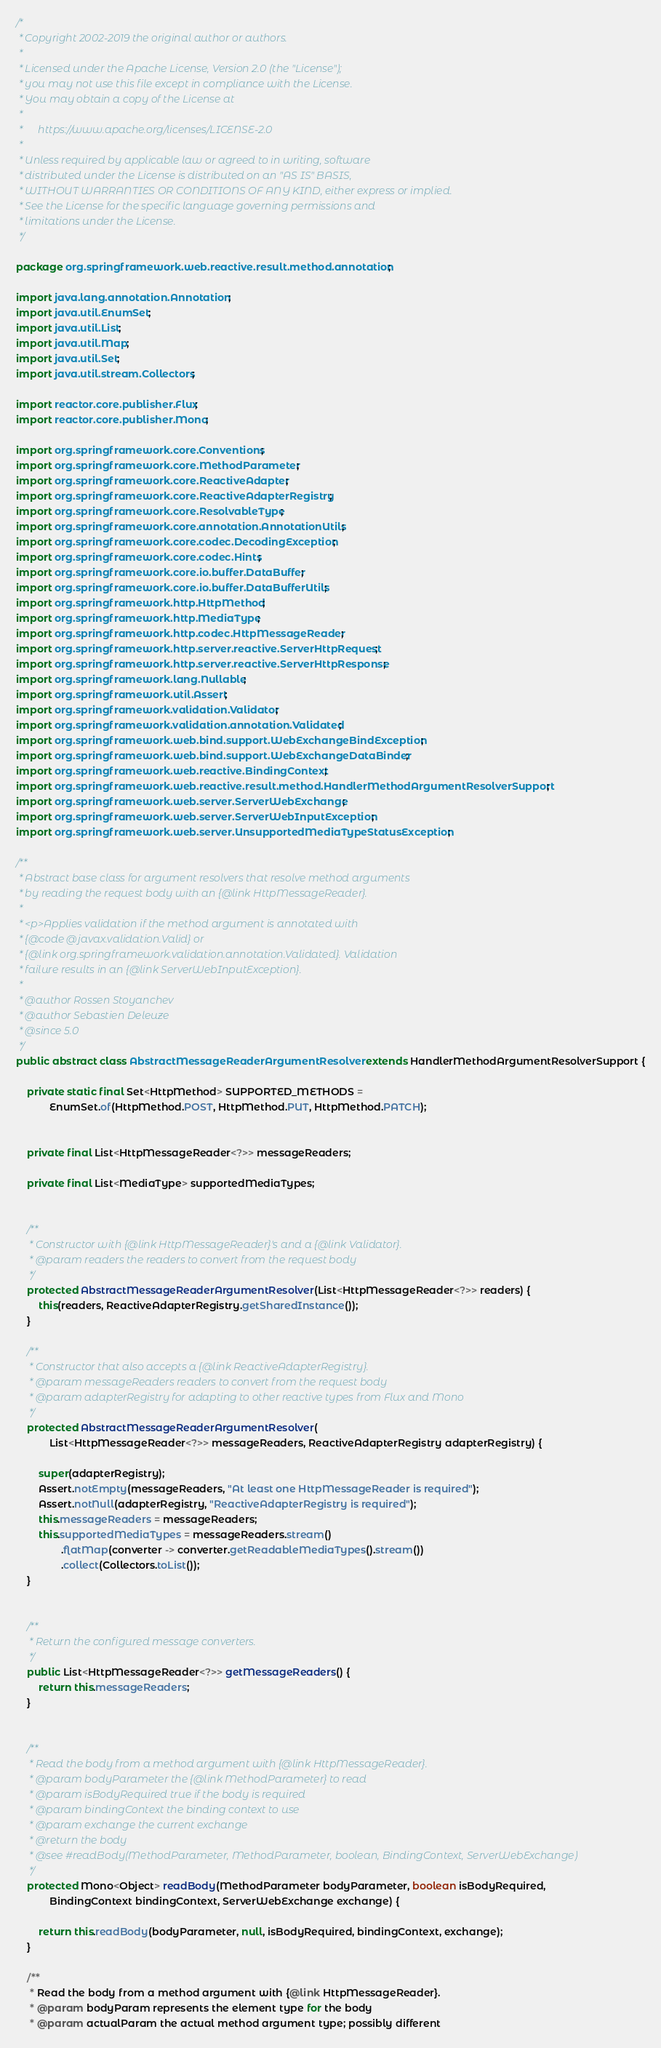<code> <loc_0><loc_0><loc_500><loc_500><_Java_>/*
 * Copyright 2002-2019 the original author or authors.
 *
 * Licensed under the Apache License, Version 2.0 (the "License");
 * you may not use this file except in compliance with the License.
 * You may obtain a copy of the License at
 *
 *      https://www.apache.org/licenses/LICENSE-2.0
 *
 * Unless required by applicable law or agreed to in writing, software
 * distributed under the License is distributed on an "AS IS" BASIS,
 * WITHOUT WARRANTIES OR CONDITIONS OF ANY KIND, either express or implied.
 * See the License for the specific language governing permissions and
 * limitations under the License.
 */

package org.springframework.web.reactive.result.method.annotation;

import java.lang.annotation.Annotation;
import java.util.EnumSet;
import java.util.List;
import java.util.Map;
import java.util.Set;
import java.util.stream.Collectors;

import reactor.core.publisher.Flux;
import reactor.core.publisher.Mono;

import org.springframework.core.Conventions;
import org.springframework.core.MethodParameter;
import org.springframework.core.ReactiveAdapter;
import org.springframework.core.ReactiveAdapterRegistry;
import org.springframework.core.ResolvableType;
import org.springframework.core.annotation.AnnotationUtils;
import org.springframework.core.codec.DecodingException;
import org.springframework.core.codec.Hints;
import org.springframework.core.io.buffer.DataBuffer;
import org.springframework.core.io.buffer.DataBufferUtils;
import org.springframework.http.HttpMethod;
import org.springframework.http.MediaType;
import org.springframework.http.codec.HttpMessageReader;
import org.springframework.http.server.reactive.ServerHttpRequest;
import org.springframework.http.server.reactive.ServerHttpResponse;
import org.springframework.lang.Nullable;
import org.springframework.util.Assert;
import org.springframework.validation.Validator;
import org.springframework.validation.annotation.Validated;
import org.springframework.web.bind.support.WebExchangeBindException;
import org.springframework.web.bind.support.WebExchangeDataBinder;
import org.springframework.web.reactive.BindingContext;
import org.springframework.web.reactive.result.method.HandlerMethodArgumentResolverSupport;
import org.springframework.web.server.ServerWebExchange;
import org.springframework.web.server.ServerWebInputException;
import org.springframework.web.server.UnsupportedMediaTypeStatusException;

/**
 * Abstract base class for argument resolvers that resolve method arguments
 * by reading the request body with an {@link HttpMessageReader}.
 *
 * <p>Applies validation if the method argument is annotated with
 * {@code @javax.validation.Valid} or
 * {@link org.springframework.validation.annotation.Validated}. Validation
 * failure results in an {@link ServerWebInputException}.
 *
 * @author Rossen Stoyanchev
 * @author Sebastien Deleuze
 * @since 5.0
 */
public abstract class AbstractMessageReaderArgumentResolver extends HandlerMethodArgumentResolverSupport {

	private static final Set<HttpMethod> SUPPORTED_METHODS =
			EnumSet.of(HttpMethod.POST, HttpMethod.PUT, HttpMethod.PATCH);


	private final List<HttpMessageReader<?>> messageReaders;

	private final List<MediaType> supportedMediaTypes;


	/**
	 * Constructor with {@link HttpMessageReader}'s and a {@link Validator}.
	 * @param readers the readers to convert from the request body
	 */
	protected AbstractMessageReaderArgumentResolver(List<HttpMessageReader<?>> readers) {
		this(readers, ReactiveAdapterRegistry.getSharedInstance());
	}

	/**
	 * Constructor that also accepts a {@link ReactiveAdapterRegistry}.
	 * @param messageReaders readers to convert from the request body
	 * @param adapterRegistry for adapting to other reactive types from Flux and Mono
	 */
	protected AbstractMessageReaderArgumentResolver(
			List<HttpMessageReader<?>> messageReaders, ReactiveAdapterRegistry adapterRegistry) {

		super(adapterRegistry);
		Assert.notEmpty(messageReaders, "At least one HttpMessageReader is required");
		Assert.notNull(adapterRegistry, "ReactiveAdapterRegistry is required");
		this.messageReaders = messageReaders;
		this.supportedMediaTypes = messageReaders.stream()
				.flatMap(converter -> converter.getReadableMediaTypes().stream())
				.collect(Collectors.toList());
	}


	/**
	 * Return the configured message converters.
	 */
	public List<HttpMessageReader<?>> getMessageReaders() {
		return this.messageReaders;
	}


	/**
	 * Read the body from a method argument with {@link HttpMessageReader}.
	 * @param bodyParameter the {@link MethodParameter} to read
	 * @param isBodyRequired true if the body is required
	 * @param bindingContext the binding context to use
	 * @param exchange the current exchange
	 * @return the body
	 * @see #readBody(MethodParameter, MethodParameter, boolean, BindingContext, ServerWebExchange)
	 */
	protected Mono<Object> readBody(MethodParameter bodyParameter, boolean isBodyRequired,
			BindingContext bindingContext, ServerWebExchange exchange) {

		return this.readBody(bodyParameter, null, isBodyRequired, bindingContext, exchange);
	}

	/**
	 * Read the body from a method argument with {@link HttpMessageReader}.
	 * @param bodyParam represents the element type for the body
	 * @param actualParam the actual method argument type; possibly different</code> 